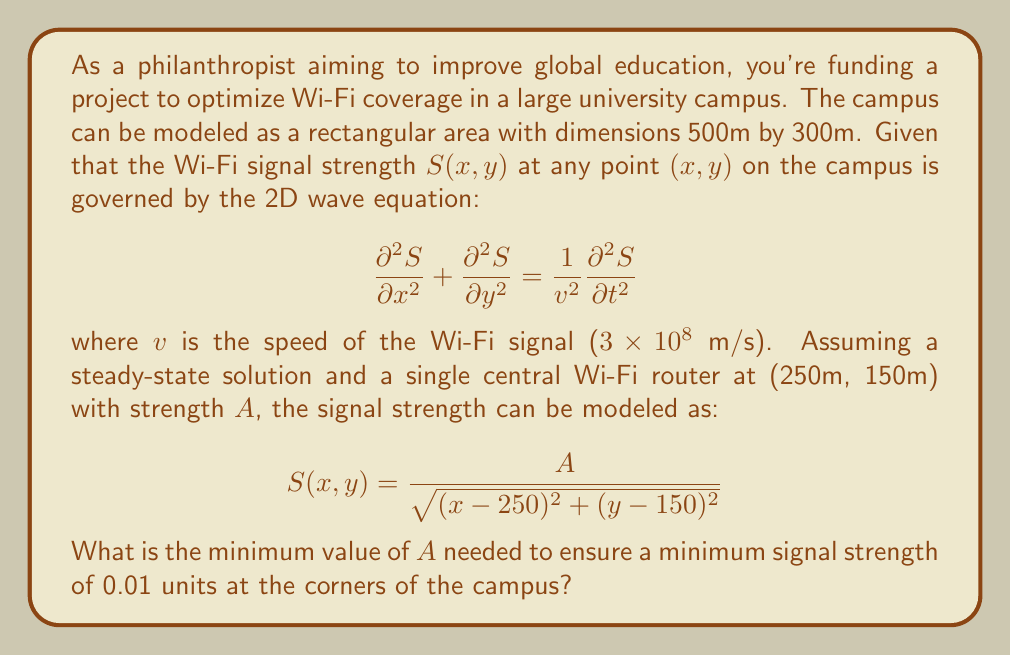Show me your answer to this math problem. Let's approach this step-by-step:

1) The corners of the campus are at (0,0), (500,0), (0,300), and (500,300).

2) Due to symmetry, we only need to check one corner. Let's use (0,0).

3) The distance from the router to (0,0) is:
   $$d = \sqrt{(0-250)^2 + (0-150)^2} = \sqrt{250^2 + 150^2} = \sqrt{85000} \approx 291.55$$

4) We want the signal strength at this corner to be at least 0.01. Using the given equation:

   $$0.01 = \frac{A}{\sqrt{85000}}$$

5) Solving for A:

   $$A = 0.01 * \sqrt{85000} = 0.01 * 291.55 = 2.9155$$

6) Therefore, the minimum value of A needed is approximately 2.9155 units.

7) To verify, let's check the signal strength at (500,300):

   $$S(500,300) = \frac{2.9155}{\sqrt{(500-250)^2 + (300-150)^2}} = \frac{2.9155}{\sqrt{85000}} = 0.01$$

This confirms that our calculated A provides the minimum required signal strength at all corners.
Answer: 2.9155 units 